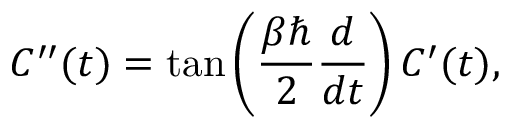<formula> <loc_0><loc_0><loc_500><loc_500>C ^ { \prime \prime } ( t ) = \tan \left ( \frac { \beta } { 2 } \frac { d } { d t } \right ) C ^ { \prime } ( t ) ,</formula> 